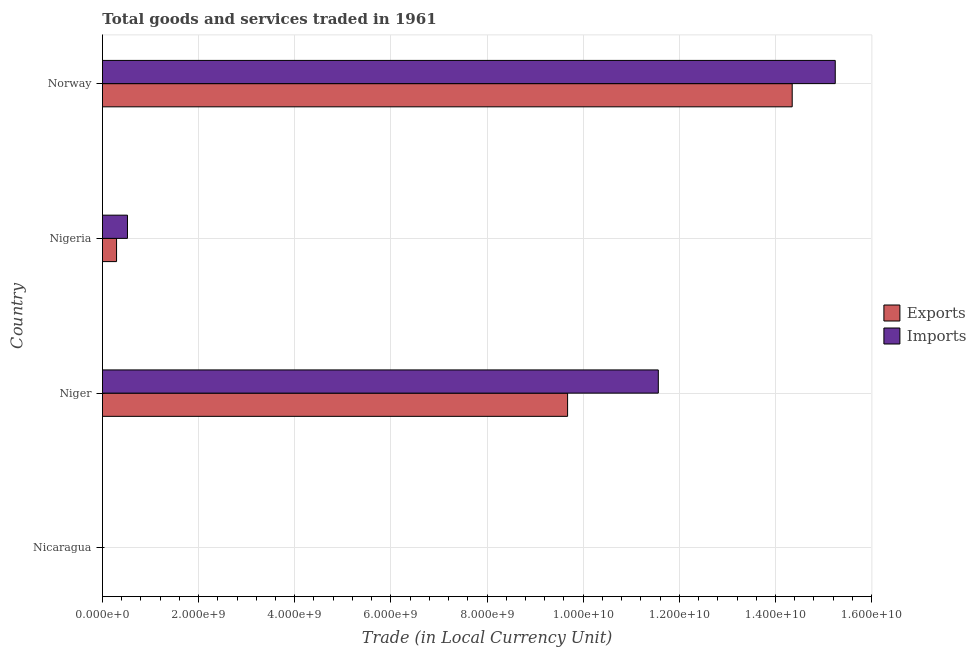How many different coloured bars are there?
Ensure brevity in your answer.  2. Are the number of bars on each tick of the Y-axis equal?
Ensure brevity in your answer.  Yes. How many bars are there on the 2nd tick from the top?
Make the answer very short. 2. What is the label of the 2nd group of bars from the top?
Keep it short and to the point. Nigeria. In how many cases, is the number of bars for a given country not equal to the number of legend labels?
Make the answer very short. 0. What is the export of goods and services in Norway?
Offer a very short reply. 1.43e+1. Across all countries, what is the maximum imports of goods and services?
Provide a short and direct response. 1.52e+1. Across all countries, what is the minimum imports of goods and services?
Your answer should be very brief. 0.12. In which country was the imports of goods and services maximum?
Provide a succinct answer. Norway. In which country was the export of goods and services minimum?
Your response must be concise. Nicaragua. What is the total imports of goods and services in the graph?
Ensure brevity in your answer.  2.73e+1. What is the difference between the export of goods and services in Nigeria and that in Norway?
Keep it short and to the point. -1.41e+1. What is the difference between the export of goods and services in Norway and the imports of goods and services in Nigeria?
Your response must be concise. 1.38e+1. What is the average export of goods and services per country?
Provide a short and direct response. 6.08e+09. What is the difference between the export of goods and services and imports of goods and services in Nigeria?
Give a very brief answer. -2.27e+08. In how many countries, is the imports of goods and services greater than 7200000000 LCU?
Give a very brief answer. 2. Is the export of goods and services in Nigeria less than that in Norway?
Offer a terse response. Yes. Is the difference between the export of goods and services in Nicaragua and Nigeria greater than the difference between the imports of goods and services in Nicaragua and Nigeria?
Provide a short and direct response. Yes. What is the difference between the highest and the second highest imports of goods and services?
Provide a short and direct response. 3.68e+09. What is the difference between the highest and the lowest imports of goods and services?
Your response must be concise. 1.52e+1. In how many countries, is the export of goods and services greater than the average export of goods and services taken over all countries?
Your answer should be very brief. 2. Is the sum of the export of goods and services in Nicaragua and Norway greater than the maximum imports of goods and services across all countries?
Offer a terse response. No. What does the 1st bar from the top in Nicaragua represents?
Offer a very short reply. Imports. What does the 2nd bar from the bottom in Nicaragua represents?
Give a very brief answer. Imports. Are all the bars in the graph horizontal?
Ensure brevity in your answer.  Yes. Are the values on the major ticks of X-axis written in scientific E-notation?
Your answer should be compact. Yes. Where does the legend appear in the graph?
Give a very brief answer. Center right. How many legend labels are there?
Give a very brief answer. 2. What is the title of the graph?
Offer a terse response. Total goods and services traded in 1961. What is the label or title of the X-axis?
Your response must be concise. Trade (in Local Currency Unit). What is the Trade (in Local Currency Unit) in Exports in Nicaragua?
Offer a very short reply. 0.12. What is the Trade (in Local Currency Unit) of Imports in Nicaragua?
Your answer should be very brief. 0.12. What is the Trade (in Local Currency Unit) in Exports in Niger?
Make the answer very short. 9.68e+09. What is the Trade (in Local Currency Unit) of Imports in Niger?
Keep it short and to the point. 1.16e+1. What is the Trade (in Local Currency Unit) in Exports in Nigeria?
Provide a short and direct response. 2.93e+08. What is the Trade (in Local Currency Unit) of Imports in Nigeria?
Your response must be concise. 5.20e+08. What is the Trade (in Local Currency Unit) of Exports in Norway?
Your response must be concise. 1.43e+1. What is the Trade (in Local Currency Unit) in Imports in Norway?
Make the answer very short. 1.52e+1. Across all countries, what is the maximum Trade (in Local Currency Unit) of Exports?
Provide a short and direct response. 1.43e+1. Across all countries, what is the maximum Trade (in Local Currency Unit) of Imports?
Make the answer very short. 1.52e+1. Across all countries, what is the minimum Trade (in Local Currency Unit) of Exports?
Ensure brevity in your answer.  0.12. Across all countries, what is the minimum Trade (in Local Currency Unit) of Imports?
Keep it short and to the point. 0.12. What is the total Trade (in Local Currency Unit) in Exports in the graph?
Ensure brevity in your answer.  2.43e+1. What is the total Trade (in Local Currency Unit) of Imports in the graph?
Provide a short and direct response. 2.73e+1. What is the difference between the Trade (in Local Currency Unit) in Exports in Nicaragua and that in Niger?
Provide a succinct answer. -9.68e+09. What is the difference between the Trade (in Local Currency Unit) in Imports in Nicaragua and that in Niger?
Keep it short and to the point. -1.16e+1. What is the difference between the Trade (in Local Currency Unit) in Exports in Nicaragua and that in Nigeria?
Offer a terse response. -2.93e+08. What is the difference between the Trade (in Local Currency Unit) in Imports in Nicaragua and that in Nigeria?
Provide a succinct answer. -5.20e+08. What is the difference between the Trade (in Local Currency Unit) of Exports in Nicaragua and that in Norway?
Your answer should be compact. -1.43e+1. What is the difference between the Trade (in Local Currency Unit) in Imports in Nicaragua and that in Norway?
Offer a very short reply. -1.52e+1. What is the difference between the Trade (in Local Currency Unit) in Exports in Niger and that in Nigeria?
Provide a succinct answer. 9.38e+09. What is the difference between the Trade (in Local Currency Unit) in Imports in Niger and that in Nigeria?
Keep it short and to the point. 1.10e+1. What is the difference between the Trade (in Local Currency Unit) in Exports in Niger and that in Norway?
Provide a short and direct response. -4.67e+09. What is the difference between the Trade (in Local Currency Unit) in Imports in Niger and that in Norway?
Provide a short and direct response. -3.68e+09. What is the difference between the Trade (in Local Currency Unit) in Exports in Nigeria and that in Norway?
Keep it short and to the point. -1.41e+1. What is the difference between the Trade (in Local Currency Unit) of Imports in Nigeria and that in Norway?
Your answer should be very brief. -1.47e+1. What is the difference between the Trade (in Local Currency Unit) of Exports in Nicaragua and the Trade (in Local Currency Unit) of Imports in Niger?
Provide a succinct answer. -1.16e+1. What is the difference between the Trade (in Local Currency Unit) of Exports in Nicaragua and the Trade (in Local Currency Unit) of Imports in Nigeria?
Your answer should be compact. -5.20e+08. What is the difference between the Trade (in Local Currency Unit) of Exports in Nicaragua and the Trade (in Local Currency Unit) of Imports in Norway?
Make the answer very short. -1.52e+1. What is the difference between the Trade (in Local Currency Unit) of Exports in Niger and the Trade (in Local Currency Unit) of Imports in Nigeria?
Keep it short and to the point. 9.16e+09. What is the difference between the Trade (in Local Currency Unit) in Exports in Niger and the Trade (in Local Currency Unit) in Imports in Norway?
Ensure brevity in your answer.  -5.57e+09. What is the difference between the Trade (in Local Currency Unit) of Exports in Nigeria and the Trade (in Local Currency Unit) of Imports in Norway?
Ensure brevity in your answer.  -1.50e+1. What is the average Trade (in Local Currency Unit) in Exports per country?
Provide a short and direct response. 6.08e+09. What is the average Trade (in Local Currency Unit) of Imports per country?
Give a very brief answer. 6.83e+09. What is the difference between the Trade (in Local Currency Unit) in Exports and Trade (in Local Currency Unit) in Imports in Nicaragua?
Your response must be concise. -0.01. What is the difference between the Trade (in Local Currency Unit) in Exports and Trade (in Local Currency Unit) in Imports in Niger?
Keep it short and to the point. -1.89e+09. What is the difference between the Trade (in Local Currency Unit) of Exports and Trade (in Local Currency Unit) of Imports in Nigeria?
Ensure brevity in your answer.  -2.27e+08. What is the difference between the Trade (in Local Currency Unit) in Exports and Trade (in Local Currency Unit) in Imports in Norway?
Provide a short and direct response. -8.96e+08. What is the ratio of the Trade (in Local Currency Unit) of Exports in Nicaragua to that in Niger?
Your answer should be very brief. 0. What is the ratio of the Trade (in Local Currency Unit) of Imports in Nicaragua to that in Niger?
Your answer should be very brief. 0. What is the ratio of the Trade (in Local Currency Unit) in Imports in Nicaragua to that in Nigeria?
Your answer should be compact. 0. What is the ratio of the Trade (in Local Currency Unit) of Imports in Nicaragua to that in Norway?
Keep it short and to the point. 0. What is the ratio of the Trade (in Local Currency Unit) of Exports in Niger to that in Nigeria?
Your answer should be compact. 33.01. What is the ratio of the Trade (in Local Currency Unit) in Imports in Niger to that in Nigeria?
Your answer should be very brief. 22.23. What is the ratio of the Trade (in Local Currency Unit) in Exports in Niger to that in Norway?
Give a very brief answer. 0.67. What is the ratio of the Trade (in Local Currency Unit) of Imports in Niger to that in Norway?
Keep it short and to the point. 0.76. What is the ratio of the Trade (in Local Currency Unit) of Exports in Nigeria to that in Norway?
Offer a terse response. 0.02. What is the ratio of the Trade (in Local Currency Unit) in Imports in Nigeria to that in Norway?
Provide a short and direct response. 0.03. What is the difference between the highest and the second highest Trade (in Local Currency Unit) in Exports?
Give a very brief answer. 4.67e+09. What is the difference between the highest and the second highest Trade (in Local Currency Unit) in Imports?
Provide a succinct answer. 3.68e+09. What is the difference between the highest and the lowest Trade (in Local Currency Unit) in Exports?
Provide a succinct answer. 1.43e+1. What is the difference between the highest and the lowest Trade (in Local Currency Unit) of Imports?
Make the answer very short. 1.52e+1. 